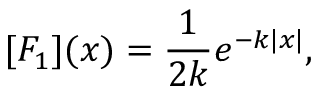<formula> <loc_0><loc_0><loc_500><loc_500>[ F _ { 1 } ] ( x ) = \frac { 1 } { 2 k } e ^ { - k | x | } ,</formula> 